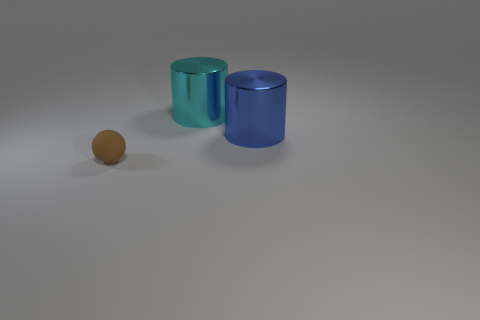Are there any other things that have the same size as the brown rubber thing?
Your answer should be very brief. No. How many things are things that are on the right side of the small brown object or objects on the right side of the tiny brown rubber ball?
Make the answer very short. 2. What is the color of the metal thing that is on the right side of the object that is behind the large metal object that is in front of the cyan metal thing?
Offer a terse response. Blue. What is the size of the cylinder right of the large metallic object on the left side of the blue metallic cylinder?
Offer a terse response. Large. What is the thing that is in front of the large cyan metallic thing and on the right side of the brown matte ball made of?
Offer a terse response. Metal. There is a blue cylinder; is its size the same as the cylinder to the left of the blue metallic object?
Provide a succinct answer. Yes. Are any large cyan cylinders visible?
Your answer should be compact. Yes. There is a cylinder to the left of the big metal cylinder to the right of the large metallic cylinder that is on the left side of the large blue thing; what size is it?
Make the answer very short. Large. There is a cyan shiny cylinder; are there any large blue shiny objects right of it?
Make the answer very short. Yes. What number of big blue metal things have the same shape as the cyan thing?
Make the answer very short. 1. 